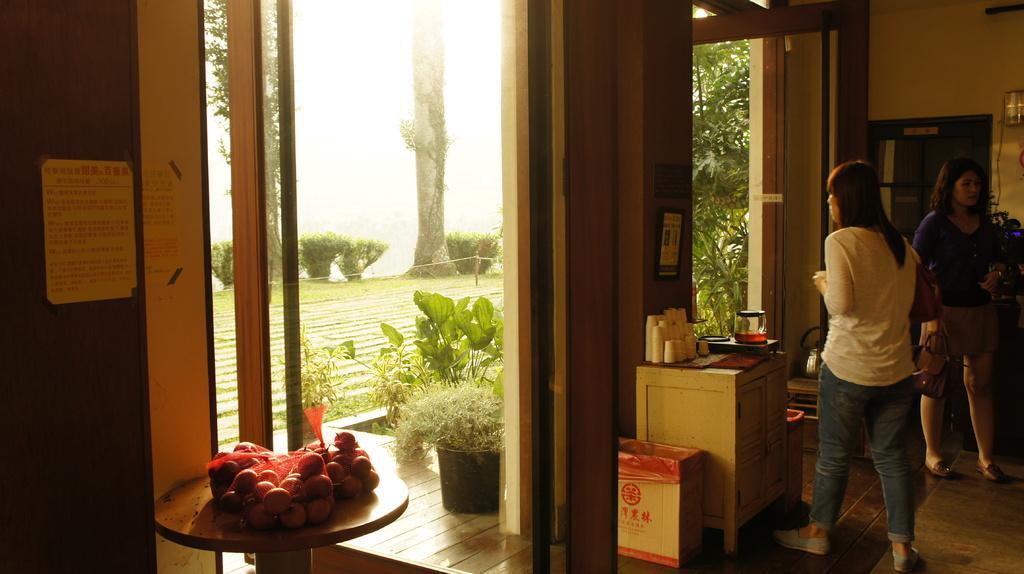Can you describe this image briefly? The two persons are standing. On the right side there is a cupboard. There is a bowl,cloth,glass on a table. On the left side there is a stool. There is a fruits on a stool. We can see in background wall,window and posters. 